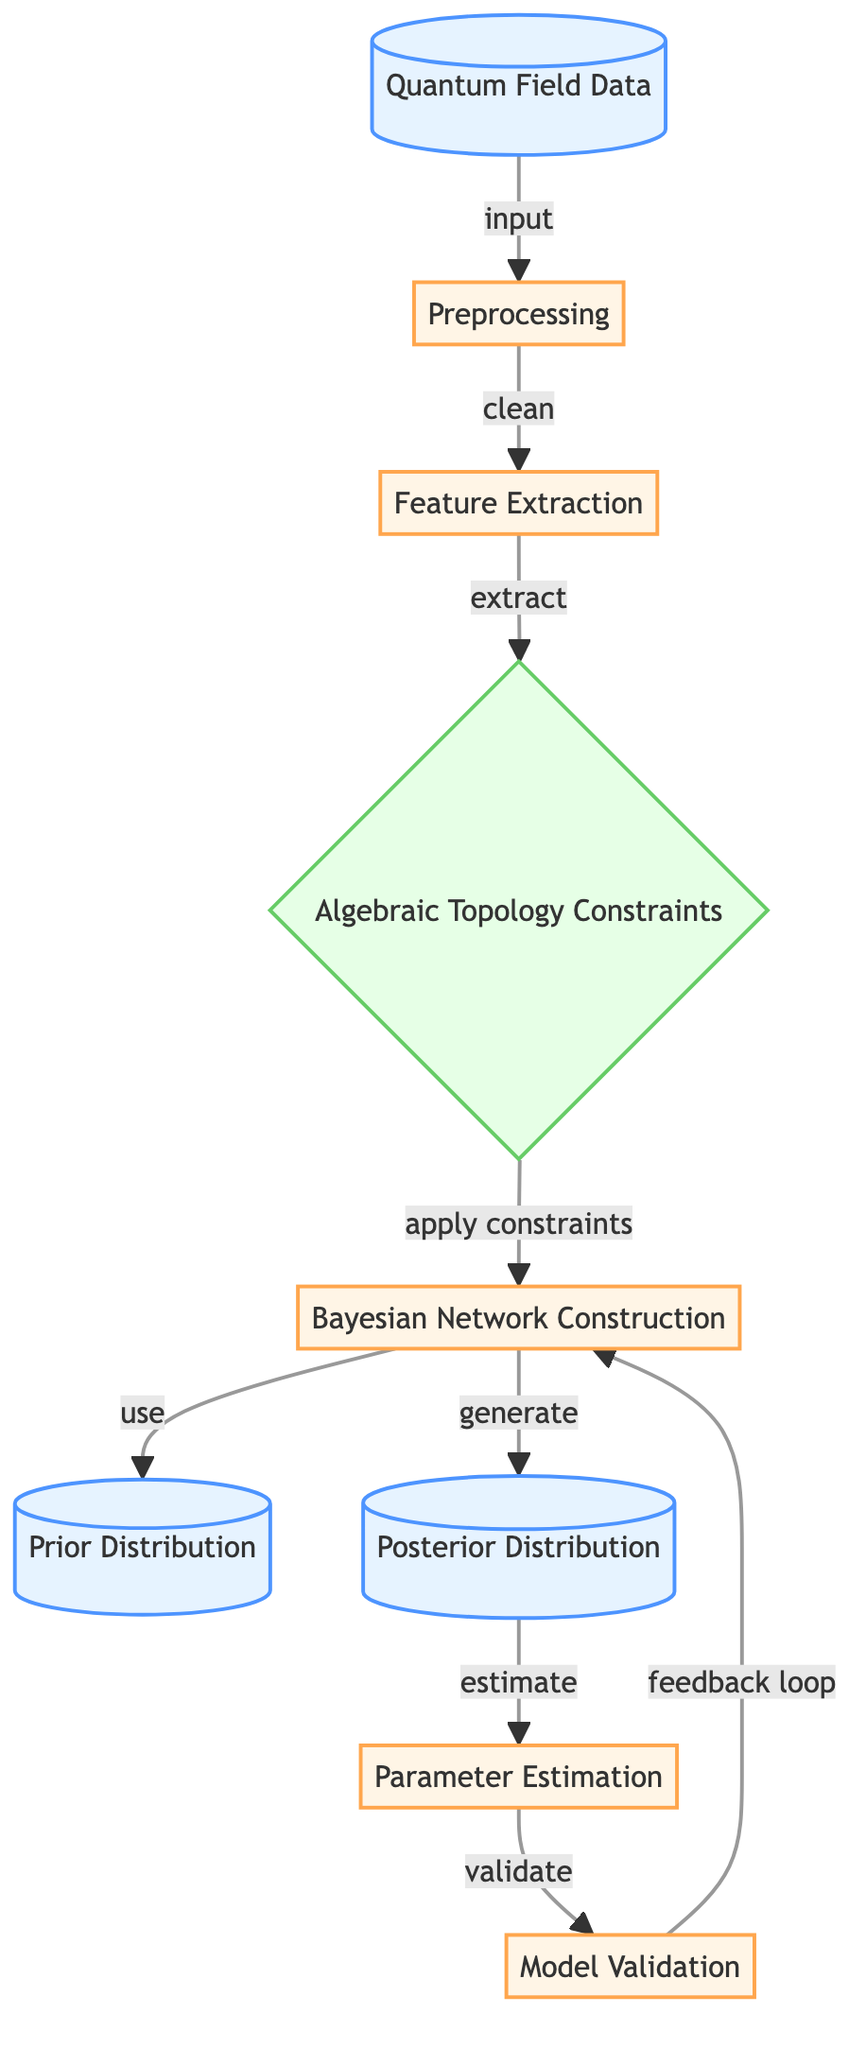What is the first node in the diagram? The first node labeled (Quantum Field Data) serves as the initial input for the entire process, indicating the starting point of the analysis.
Answer: Quantum Field Data How many process nodes are depicted in the diagram? Upon analyzing the diagram, there are five nodes categorized as processes: Preprocessing, Feature Extraction, Bayesian Network Construction, Parameter Estimation, and Model Validation.
Answer: Five What type of constraints are applied in the diagram? The diagram includes a node labeled (Algebraic Topology Constraints), which suggests that the constraints being applied are derived from algebraic topology.
Answer: Algebraic Topology Which node generates the posterior distribution? The node labeled (Posterior Distribution) is the one that is generated by the Bayesian Network Construction process, utilizing the prior distribution as input.
Answer: Posterior Distribution Describe the flow from the preprocessing to the parameter estimation. The flow starts at the preprocessing node, which leads to feature extraction, followed by applying algebraic topology constraints. The constraints then feed into the Bayesian Network Construction, which results in generating the posterior distribution. This posterior distribution is used for parameter estimation.
Answer: Preprocessing to Parameter Estimation What action takes place between the posterior distribution and the parameter estimation node? The posterior distribution provides the necessary data that allows for the parameter estimation action to be computed or carried out.
Answer: Estimate How does the model validation relate to the Bayesian network construction? The model validation node takes feedback from the validation process to possibly adjust or improve the Bayesian network construction, establishing a continuous improvement loop.
Answer: Feedback loop What is the output of the parameter estimation node? The parameter estimation node outputs the estimated parameters that are utilized for understanding the underlying quantum field data.
Answer: Estimated parameters What is the role of the prior distribution in the Bayesian network? The prior distribution serves as one of the initial inputs that inform the Bayesian Network Construction, initializing the probabilistic model before updating with observed data.
Answer: Initial input What connects the posterior distribution to the model validation process? The flow indicates that the posterior distribution is utilized for estimating parameters, and this estimation is then validated in the model validation process, suggesting a sequential relationship.
Answer: Sequential relationship 